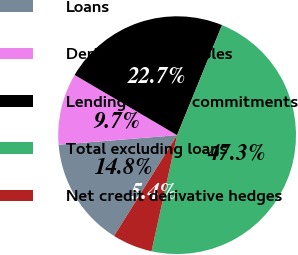Convert chart. <chart><loc_0><loc_0><loc_500><loc_500><pie_chart><fcel>Loans<fcel>Derivative receivables<fcel>Lending-related commitments<fcel>Total excluding loans<fcel>Net credit derivative hedges<nl><fcel>14.82%<fcel>9.74%<fcel>22.71%<fcel>47.28%<fcel>5.44%<nl></chart> 